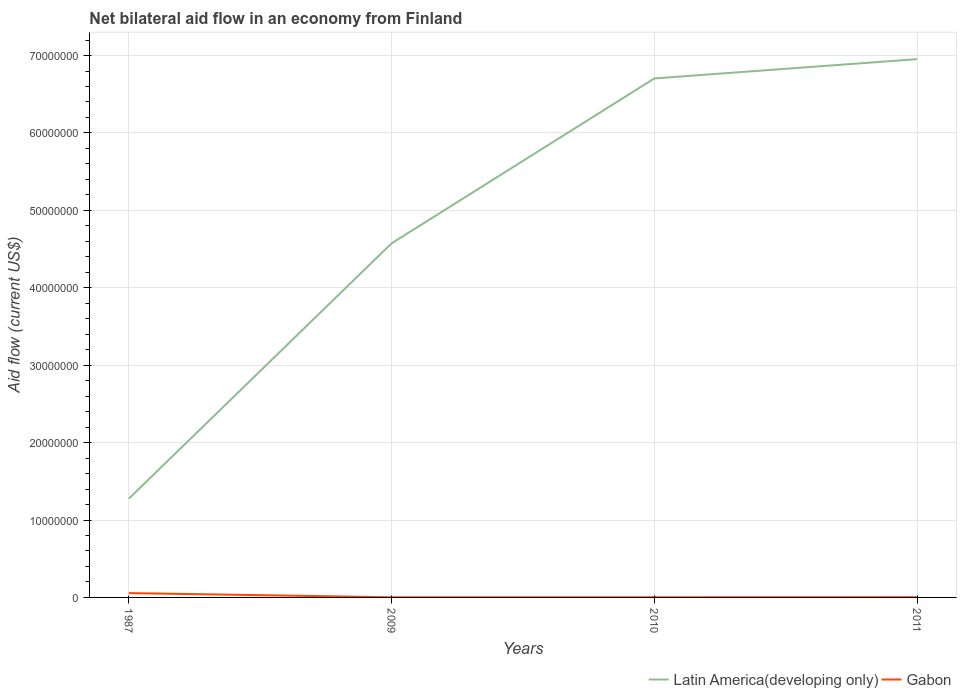Does the line corresponding to Gabon intersect with the line corresponding to Latin America(developing only)?
Your answer should be compact. No. Across all years, what is the maximum net bilateral aid flow in Gabon?
Ensure brevity in your answer.  2.00e+04. What is the total net bilateral aid flow in Latin America(developing only) in the graph?
Your answer should be very brief. -5.43e+07. What is the difference between the highest and the second highest net bilateral aid flow in Gabon?
Keep it short and to the point. 5.40e+05. Is the net bilateral aid flow in Latin America(developing only) strictly greater than the net bilateral aid flow in Gabon over the years?
Keep it short and to the point. No. Are the values on the major ticks of Y-axis written in scientific E-notation?
Offer a very short reply. No. Does the graph contain any zero values?
Provide a short and direct response. No. Where does the legend appear in the graph?
Make the answer very short. Bottom right. What is the title of the graph?
Give a very brief answer. Net bilateral aid flow in an economy from Finland. What is the label or title of the Y-axis?
Provide a short and direct response. Aid flow (current US$). What is the Aid flow (current US$) in Latin America(developing only) in 1987?
Offer a terse response. 1.28e+07. What is the Aid flow (current US$) of Gabon in 1987?
Provide a short and direct response. 5.60e+05. What is the Aid flow (current US$) in Latin America(developing only) in 2009?
Offer a terse response. 4.57e+07. What is the Aid flow (current US$) in Latin America(developing only) in 2010?
Keep it short and to the point. 6.70e+07. What is the Aid flow (current US$) in Latin America(developing only) in 2011?
Your answer should be very brief. 6.95e+07. What is the Aid flow (current US$) in Gabon in 2011?
Offer a terse response. 3.00e+04. Across all years, what is the maximum Aid flow (current US$) of Latin America(developing only)?
Your response must be concise. 6.95e+07. Across all years, what is the maximum Aid flow (current US$) in Gabon?
Make the answer very short. 5.60e+05. Across all years, what is the minimum Aid flow (current US$) of Latin America(developing only)?
Make the answer very short. 1.28e+07. Across all years, what is the minimum Aid flow (current US$) in Gabon?
Make the answer very short. 2.00e+04. What is the total Aid flow (current US$) of Latin America(developing only) in the graph?
Provide a short and direct response. 1.95e+08. What is the total Aid flow (current US$) in Gabon in the graph?
Your response must be concise. 6.30e+05. What is the difference between the Aid flow (current US$) in Latin America(developing only) in 1987 and that in 2009?
Your response must be concise. -3.30e+07. What is the difference between the Aid flow (current US$) in Gabon in 1987 and that in 2009?
Offer a terse response. 5.40e+05. What is the difference between the Aid flow (current US$) in Latin America(developing only) in 1987 and that in 2010?
Make the answer very short. -5.43e+07. What is the difference between the Aid flow (current US$) of Gabon in 1987 and that in 2010?
Provide a succinct answer. 5.40e+05. What is the difference between the Aid flow (current US$) in Latin America(developing only) in 1987 and that in 2011?
Keep it short and to the point. -5.68e+07. What is the difference between the Aid flow (current US$) in Gabon in 1987 and that in 2011?
Ensure brevity in your answer.  5.30e+05. What is the difference between the Aid flow (current US$) of Latin America(developing only) in 2009 and that in 2010?
Provide a succinct answer. -2.13e+07. What is the difference between the Aid flow (current US$) in Gabon in 2009 and that in 2010?
Provide a succinct answer. 0. What is the difference between the Aid flow (current US$) in Latin America(developing only) in 2009 and that in 2011?
Your answer should be compact. -2.38e+07. What is the difference between the Aid flow (current US$) in Gabon in 2009 and that in 2011?
Provide a succinct answer. -10000. What is the difference between the Aid flow (current US$) in Latin America(developing only) in 2010 and that in 2011?
Give a very brief answer. -2.49e+06. What is the difference between the Aid flow (current US$) of Gabon in 2010 and that in 2011?
Give a very brief answer. -10000. What is the difference between the Aid flow (current US$) in Latin America(developing only) in 1987 and the Aid flow (current US$) in Gabon in 2009?
Your answer should be compact. 1.27e+07. What is the difference between the Aid flow (current US$) of Latin America(developing only) in 1987 and the Aid flow (current US$) of Gabon in 2010?
Provide a short and direct response. 1.27e+07. What is the difference between the Aid flow (current US$) of Latin America(developing only) in 1987 and the Aid flow (current US$) of Gabon in 2011?
Your response must be concise. 1.27e+07. What is the difference between the Aid flow (current US$) in Latin America(developing only) in 2009 and the Aid flow (current US$) in Gabon in 2010?
Make the answer very short. 4.57e+07. What is the difference between the Aid flow (current US$) in Latin America(developing only) in 2009 and the Aid flow (current US$) in Gabon in 2011?
Ensure brevity in your answer.  4.57e+07. What is the difference between the Aid flow (current US$) in Latin America(developing only) in 2010 and the Aid flow (current US$) in Gabon in 2011?
Your answer should be very brief. 6.70e+07. What is the average Aid flow (current US$) of Latin America(developing only) per year?
Give a very brief answer. 4.88e+07. What is the average Aid flow (current US$) of Gabon per year?
Make the answer very short. 1.58e+05. In the year 1987, what is the difference between the Aid flow (current US$) of Latin America(developing only) and Aid flow (current US$) of Gabon?
Offer a terse response. 1.22e+07. In the year 2009, what is the difference between the Aid flow (current US$) in Latin America(developing only) and Aid flow (current US$) in Gabon?
Provide a succinct answer. 4.57e+07. In the year 2010, what is the difference between the Aid flow (current US$) of Latin America(developing only) and Aid flow (current US$) of Gabon?
Give a very brief answer. 6.70e+07. In the year 2011, what is the difference between the Aid flow (current US$) of Latin America(developing only) and Aid flow (current US$) of Gabon?
Make the answer very short. 6.95e+07. What is the ratio of the Aid flow (current US$) in Latin America(developing only) in 1987 to that in 2009?
Ensure brevity in your answer.  0.28. What is the ratio of the Aid flow (current US$) in Latin America(developing only) in 1987 to that in 2010?
Offer a terse response. 0.19. What is the ratio of the Aid flow (current US$) of Gabon in 1987 to that in 2010?
Offer a terse response. 28. What is the ratio of the Aid flow (current US$) of Latin America(developing only) in 1987 to that in 2011?
Offer a terse response. 0.18. What is the ratio of the Aid flow (current US$) of Gabon in 1987 to that in 2011?
Your answer should be compact. 18.67. What is the ratio of the Aid flow (current US$) in Latin America(developing only) in 2009 to that in 2010?
Provide a short and direct response. 0.68. What is the ratio of the Aid flow (current US$) in Latin America(developing only) in 2009 to that in 2011?
Make the answer very short. 0.66. What is the ratio of the Aid flow (current US$) of Latin America(developing only) in 2010 to that in 2011?
Offer a very short reply. 0.96. What is the ratio of the Aid flow (current US$) in Gabon in 2010 to that in 2011?
Offer a terse response. 0.67. What is the difference between the highest and the second highest Aid flow (current US$) in Latin America(developing only)?
Provide a short and direct response. 2.49e+06. What is the difference between the highest and the second highest Aid flow (current US$) of Gabon?
Ensure brevity in your answer.  5.30e+05. What is the difference between the highest and the lowest Aid flow (current US$) in Latin America(developing only)?
Provide a succinct answer. 5.68e+07. What is the difference between the highest and the lowest Aid flow (current US$) of Gabon?
Make the answer very short. 5.40e+05. 